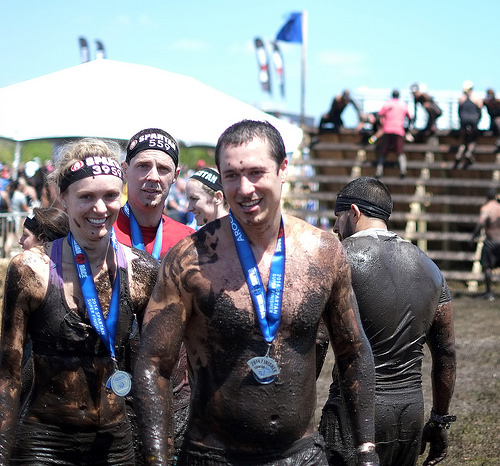<image>
Is the men on the women? No. The men is not positioned on the women. They may be near each other, but the men is not supported by or resting on top of the women. 